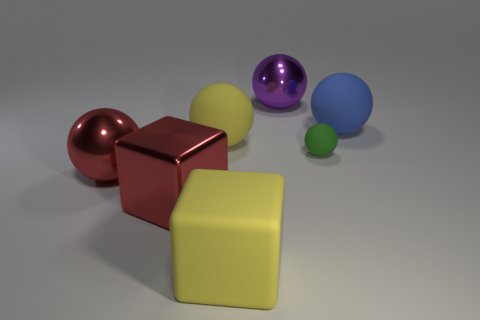Subtract 2 spheres. How many spheres are left? 3 Subtract all yellow balls. How many balls are left? 4 Subtract all green balls. How many balls are left? 4 Subtract all red balls. Subtract all yellow cylinders. How many balls are left? 4 Add 1 blue balls. How many objects exist? 8 Subtract all blocks. How many objects are left? 5 Add 3 large rubber things. How many large rubber things are left? 6 Add 6 large blue balls. How many large blue balls exist? 7 Subtract 0 green cylinders. How many objects are left? 7 Subtract all yellow balls. Subtract all big cyan metal cylinders. How many objects are left? 6 